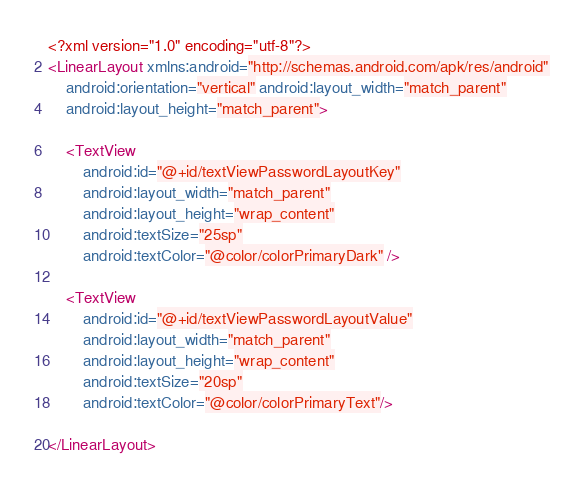Convert code to text. <code><loc_0><loc_0><loc_500><loc_500><_XML_><?xml version="1.0" encoding="utf-8"?>
<LinearLayout xmlns:android="http://schemas.android.com/apk/res/android"
    android:orientation="vertical" android:layout_width="match_parent"
    android:layout_height="match_parent">

    <TextView
        android:id="@+id/textViewPasswordLayoutKey"
        android:layout_width="match_parent"
        android:layout_height="wrap_content"
        android:textSize="25sp"
        android:textColor="@color/colorPrimaryDark" />

    <TextView
        android:id="@+id/textViewPasswordLayoutValue"
        android:layout_width="match_parent"
        android:layout_height="wrap_content"
        android:textSize="20sp"
        android:textColor="@color/colorPrimaryText"/>

</LinearLayout></code> 